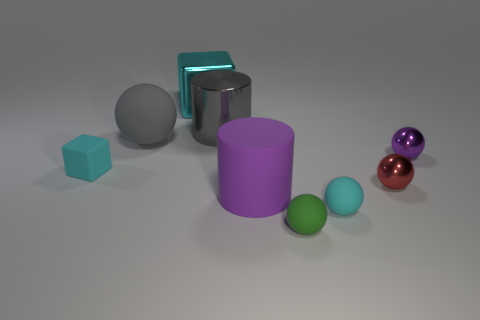There is a cylinder that is made of the same material as the big cyan thing; what color is it?
Offer a very short reply. Gray. There is a shiny cube; is its color the same as the block in front of the purple ball?
Give a very brief answer. Yes. There is a large cyan block behind the cyan rubber object that is to the right of the tiny green matte thing; are there any purple things in front of it?
Provide a short and direct response. Yes. There is a cyan thing that is the same material as the small red sphere; what shape is it?
Your answer should be very brief. Cube. What is the shape of the cyan metal object?
Offer a very short reply. Cube. There is a tiny cyan rubber thing that is right of the gray metal cylinder; is its shape the same as the green thing?
Provide a short and direct response. Yes. Are there more cylinders that are in front of the big gray metallic cylinder than green matte objects behind the big cyan block?
Provide a short and direct response. Yes. How many other things are there of the same size as the gray matte thing?
Make the answer very short. 3. There is a large gray metallic object; is its shape the same as the purple object on the left side of the tiny green rubber ball?
Make the answer very short. Yes. How many matte objects are tiny red cylinders or tiny cyan things?
Your answer should be very brief. 2. 